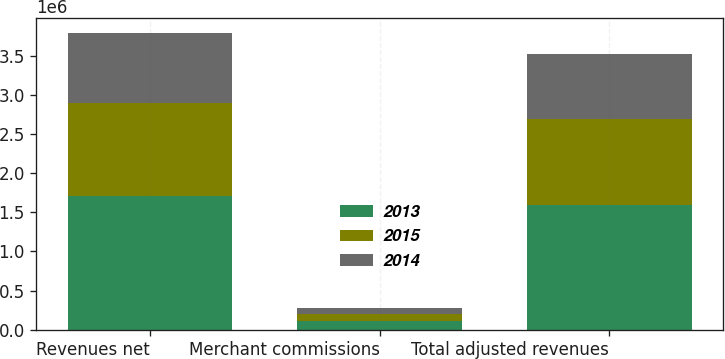<chart> <loc_0><loc_0><loc_500><loc_500><stacked_bar_chart><ecel><fcel>Revenues net<fcel>Merchant commissions<fcel>Total adjusted revenues<nl><fcel>2013<fcel>1.70286e+06<fcel>108257<fcel>1.59461e+06<nl><fcel>2015<fcel>1.19939e+06<fcel>96254<fcel>1.10314e+06<nl><fcel>2014<fcel>895171<fcel>68143<fcel>827028<nl></chart> 